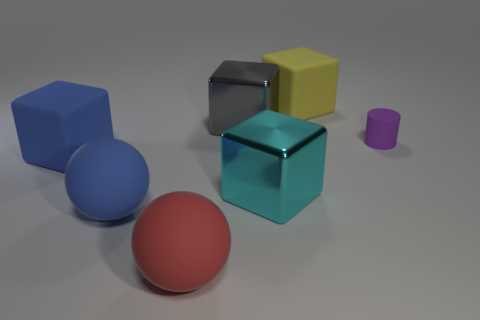Are there the same number of small purple matte things that are in front of the cyan shiny thing and small objects?
Your response must be concise. No. What shape is the object that is both right of the gray metallic thing and in front of the purple thing?
Provide a short and direct response. Cube. Do the red object and the gray shiny cube have the same size?
Offer a very short reply. Yes. Are there any other large blue cylinders made of the same material as the cylinder?
Provide a short and direct response. No. How many rubber things are to the left of the tiny object and behind the large red matte object?
Your answer should be compact. 3. What is the material of the yellow thing behind the small rubber cylinder?
Your answer should be compact. Rubber. What number of small cylinders have the same color as the tiny rubber object?
Make the answer very short. 0. There is a cylinder that is made of the same material as the red ball; what is its size?
Your response must be concise. Small. What number of things are tiny red matte cubes or small things?
Your answer should be compact. 1. What is the color of the big metallic block behind the cylinder?
Provide a short and direct response. Gray. 